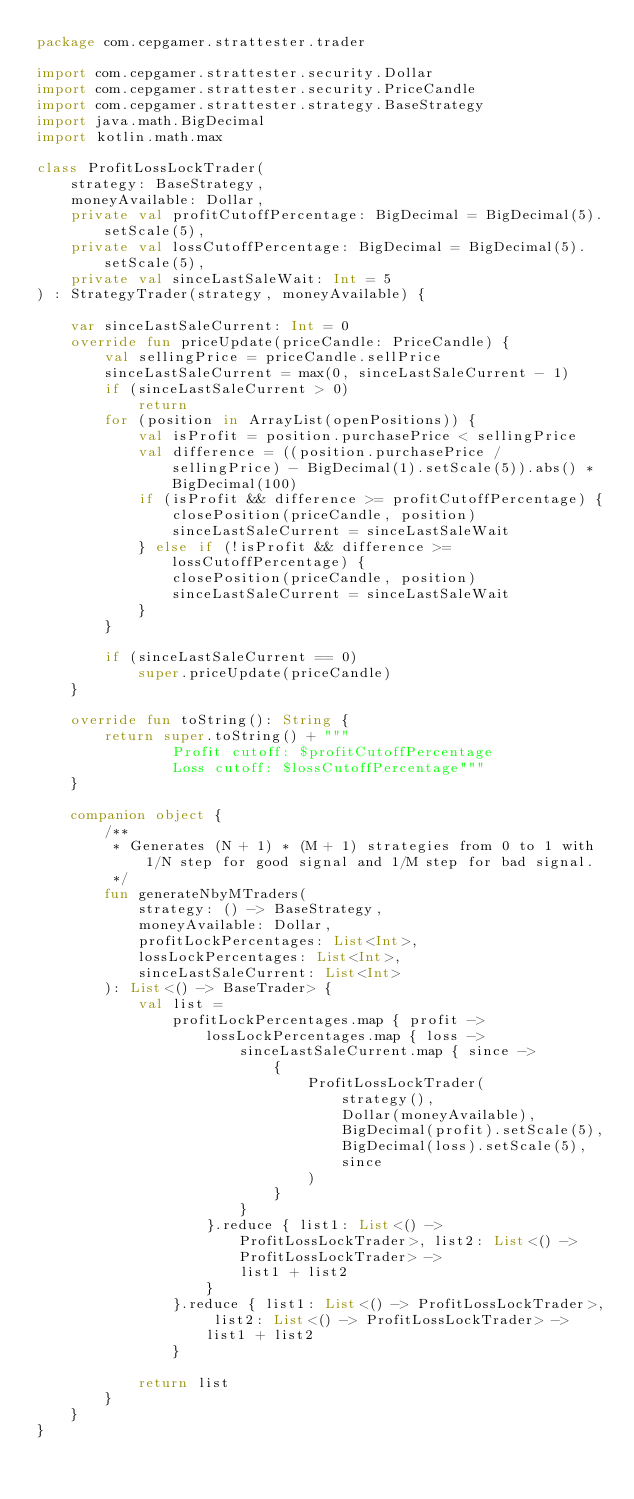Convert code to text. <code><loc_0><loc_0><loc_500><loc_500><_Kotlin_>package com.cepgamer.strattester.trader

import com.cepgamer.strattester.security.Dollar
import com.cepgamer.strattester.security.PriceCandle
import com.cepgamer.strattester.strategy.BaseStrategy
import java.math.BigDecimal
import kotlin.math.max

class ProfitLossLockTrader(
    strategy: BaseStrategy,
    moneyAvailable: Dollar,
    private val profitCutoffPercentage: BigDecimal = BigDecimal(5).setScale(5),
    private val lossCutoffPercentage: BigDecimal = BigDecimal(5).setScale(5),
    private val sinceLastSaleWait: Int = 5
) : StrategyTrader(strategy, moneyAvailable) {

    var sinceLastSaleCurrent: Int = 0
    override fun priceUpdate(priceCandle: PriceCandle) {
        val sellingPrice = priceCandle.sellPrice
        sinceLastSaleCurrent = max(0, sinceLastSaleCurrent - 1)
        if (sinceLastSaleCurrent > 0)
            return
        for (position in ArrayList(openPositions)) {
            val isProfit = position.purchasePrice < sellingPrice
            val difference = ((position.purchasePrice / sellingPrice) - BigDecimal(1).setScale(5)).abs() * BigDecimal(100)
            if (isProfit && difference >= profitCutoffPercentage) {
                closePosition(priceCandle, position)
                sinceLastSaleCurrent = sinceLastSaleWait
            } else if (!isProfit && difference >= lossCutoffPercentage) {
                closePosition(priceCandle, position)
                sinceLastSaleCurrent = sinceLastSaleWait
            }
        }

        if (sinceLastSaleCurrent == 0)
            super.priceUpdate(priceCandle)
    }

    override fun toString(): String {
        return super.toString() + """
                Profit cutoff: $profitCutoffPercentage
                Loss cutoff: $lossCutoffPercentage"""
    }

    companion object {
        /**
         * Generates (N + 1) * (M + 1) strategies from 0 to 1 with 1/N step for good signal and 1/M step for bad signal.
         */
        fun generateNbyMTraders(
            strategy: () -> BaseStrategy,
            moneyAvailable: Dollar,
            profitLockPercentages: List<Int>,
            lossLockPercentages: List<Int>,
            sinceLastSaleCurrent: List<Int>
        ): List<() -> BaseTrader> {
            val list =
                profitLockPercentages.map { profit ->
                    lossLockPercentages.map { loss ->
                        sinceLastSaleCurrent.map { since ->
                            {
                                ProfitLossLockTrader(
                                    strategy(),
                                    Dollar(moneyAvailable),
                                    BigDecimal(profit).setScale(5),
                                    BigDecimal(loss).setScale(5),
                                    since
                                )
                            }
                        }
                    }.reduce { list1: List<() -> ProfitLossLockTrader>, list2: List<() -> ProfitLossLockTrader> ->
                        list1 + list2
                    }
                }.reduce { list1: List<() -> ProfitLossLockTrader>, list2: List<() -> ProfitLossLockTrader> ->
                    list1 + list2
                }

            return list
        }
    }
}
</code> 